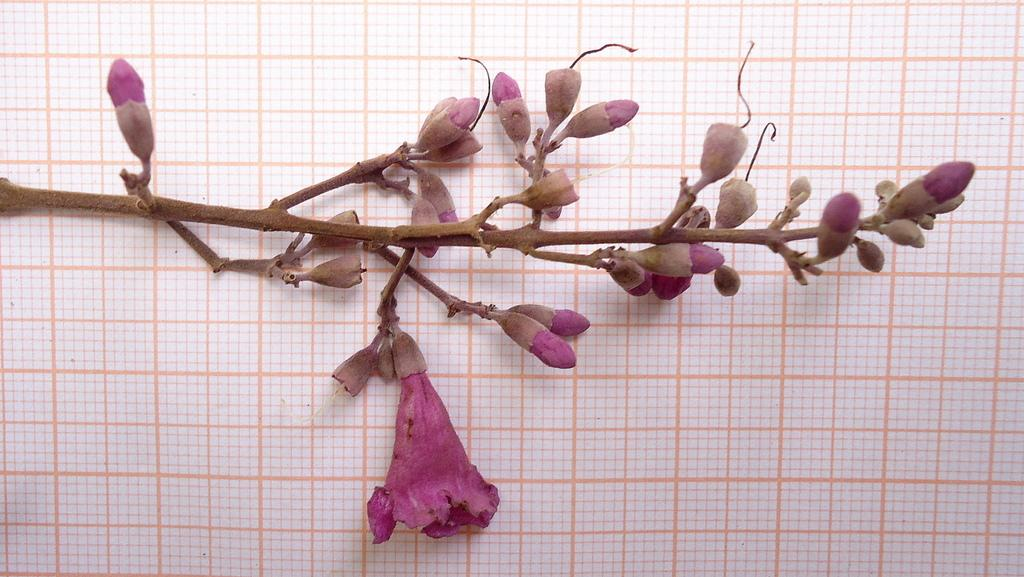What is the main subject of the image? The main subject of the image is a stem with a flower. Are there any additional features on the stem? Yes, there are buds on the stem. What can be seen in the background of the image? In the background, it appears to be a paper. How many feathers can be seen attached to the flower in the image? There are no feathers present in the image; it features a stem with a flower and buds. What stage of development is the brick shown in the image? There is no brick present in the image; it features a stem with a flower, buds, and a paper background. 